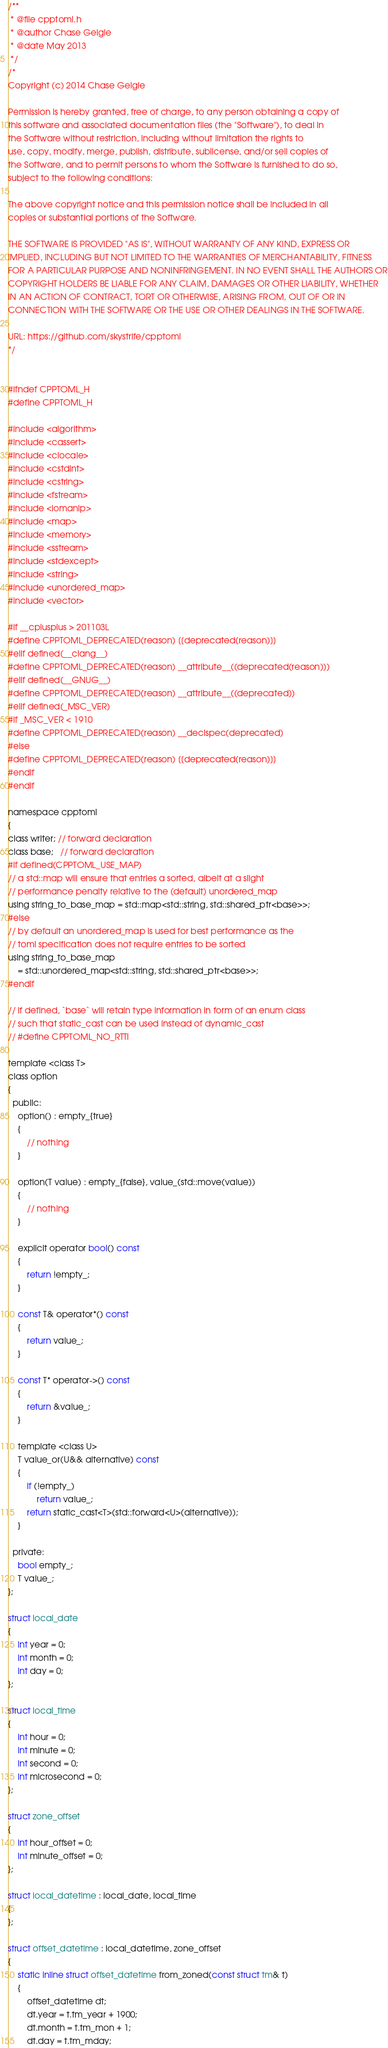<code> <loc_0><loc_0><loc_500><loc_500><_C_>/**
 * @file cpptoml.h
 * @author Chase Geigle
 * @date May 2013
 */
/*
Copyright (c) 2014 Chase Geigle

Permission is hereby granted, free of charge, to any person obtaining a copy of
this software and associated documentation files (the "Software"), to deal in
the Software without restriction, including without limitation the rights to
use, copy, modify, merge, publish, distribute, sublicense, and/or sell copies of
the Software, and to permit persons to whom the Software is furnished to do so,
subject to the following conditions:

The above copyright notice and this permission notice shall be included in all
copies or substantial portions of the Software.

THE SOFTWARE IS PROVIDED "AS IS", WITHOUT WARRANTY OF ANY KIND, EXPRESS OR
IMPLIED, INCLUDING BUT NOT LIMITED TO THE WARRANTIES OF MERCHANTABILITY, FITNESS
FOR A PARTICULAR PURPOSE AND NONINFRINGEMENT. IN NO EVENT SHALL THE AUTHORS OR
COPYRIGHT HOLDERS BE LIABLE FOR ANY CLAIM, DAMAGES OR OTHER LIABILITY, WHETHER
IN AN ACTION OF CONTRACT, TORT OR OTHERWISE, ARISING FROM, OUT OF OR IN
CONNECTION WITH THE SOFTWARE OR THE USE OR OTHER DEALINGS IN THE SOFTWARE.

URL: https://github.com/skystrife/cpptoml
*/


#ifndef CPPTOML_H
#define CPPTOML_H

#include <algorithm>
#include <cassert>
#include <clocale>
#include <cstdint>
#include <cstring>
#include <fstream>
#include <iomanip>
#include <map>
#include <memory>
#include <sstream>
#include <stdexcept>
#include <string>
#include <unordered_map>
#include <vector>

#if __cplusplus > 201103L
#define CPPTOML_DEPRECATED(reason) [[deprecated(reason)]]
#elif defined(__clang__)
#define CPPTOML_DEPRECATED(reason) __attribute__((deprecated(reason)))
#elif defined(__GNUG__)
#define CPPTOML_DEPRECATED(reason) __attribute__((deprecated))
#elif defined(_MSC_VER)
#if _MSC_VER < 1910
#define CPPTOML_DEPRECATED(reason) __declspec(deprecated)
#else
#define CPPTOML_DEPRECATED(reason) [[deprecated(reason)]]
#endif
#endif

namespace cpptoml
{
class writer; // forward declaration
class base;   // forward declaration
#if defined(CPPTOML_USE_MAP)
// a std::map will ensure that entries a sorted, albeit at a slight
// performance penalty relative to the (default) unordered_map
using string_to_base_map = std::map<std::string, std::shared_ptr<base>>;
#else
// by default an unordered_map is used for best performance as the
// toml specification does not require entries to be sorted
using string_to_base_map
    = std::unordered_map<std::string, std::shared_ptr<base>>;
#endif

// if defined, `base` will retain type information in form of an enum class
// such that static_cast can be used instead of dynamic_cast
// #define CPPTOML_NO_RTTI

template <class T>
class option
{
  public:
    option() : empty_{true}
    {
        // nothing
    }

    option(T value) : empty_{false}, value_(std::move(value))
    {
        // nothing
    }

    explicit operator bool() const
    {
        return !empty_;
    }

    const T& operator*() const
    {
        return value_;
    }

    const T* operator->() const
    {
        return &value_;
    }

    template <class U>
    T value_or(U&& alternative) const
    {
        if (!empty_)
            return value_;
        return static_cast<T>(std::forward<U>(alternative));
    }

  private:
    bool empty_;
    T value_;
};

struct local_date
{
    int year = 0;
    int month = 0;
    int day = 0;
};

struct local_time
{
    int hour = 0;
    int minute = 0;
    int second = 0;
    int microsecond = 0;
};

struct zone_offset
{
    int hour_offset = 0;
    int minute_offset = 0;
};

struct local_datetime : local_date, local_time
{
};

struct offset_datetime : local_datetime, zone_offset
{
    static inline struct offset_datetime from_zoned(const struct tm& t)
    {
        offset_datetime dt;
        dt.year = t.tm_year + 1900;
        dt.month = t.tm_mon + 1;
        dt.day = t.tm_mday;</code> 